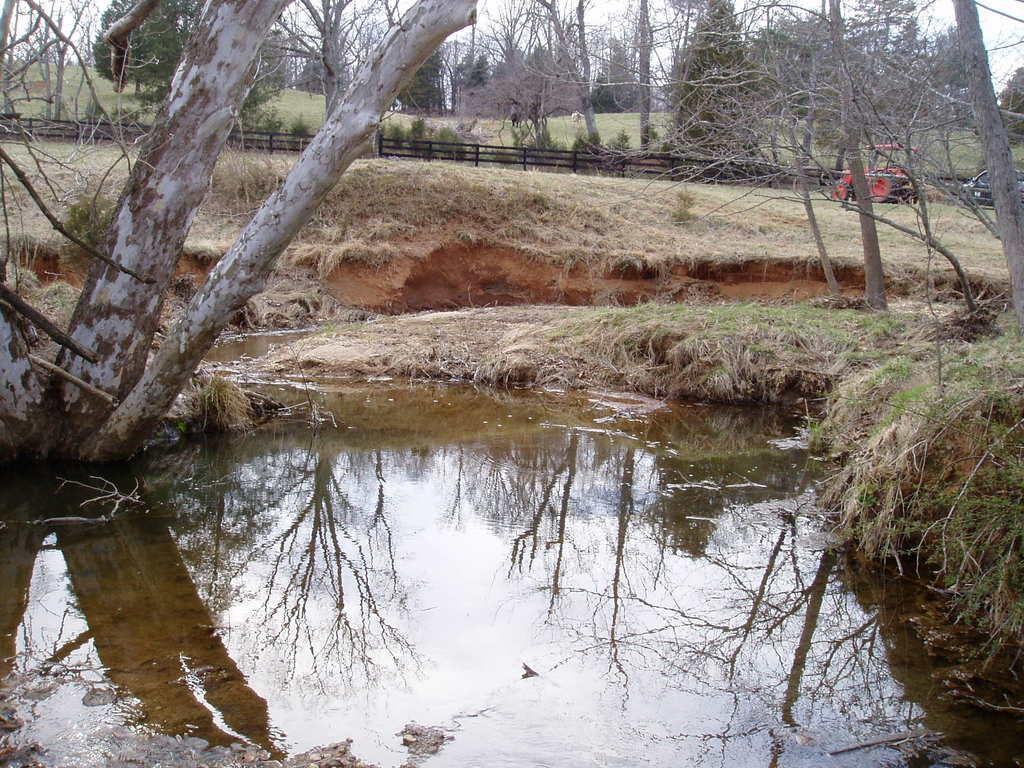What body of water is visible in the image? There is a lake in the image. What type of vegetation is present around the lake? There are trees around the lake. What structure can be seen in the image? There is a fence in the image. What type of man-made object is visible in the image? There is a vehicle in the image. How many flowers are blooming on the quilt in the image? There are no flowers or quilts present in the image. 